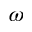<formula> <loc_0><loc_0><loc_500><loc_500>\omega</formula> 